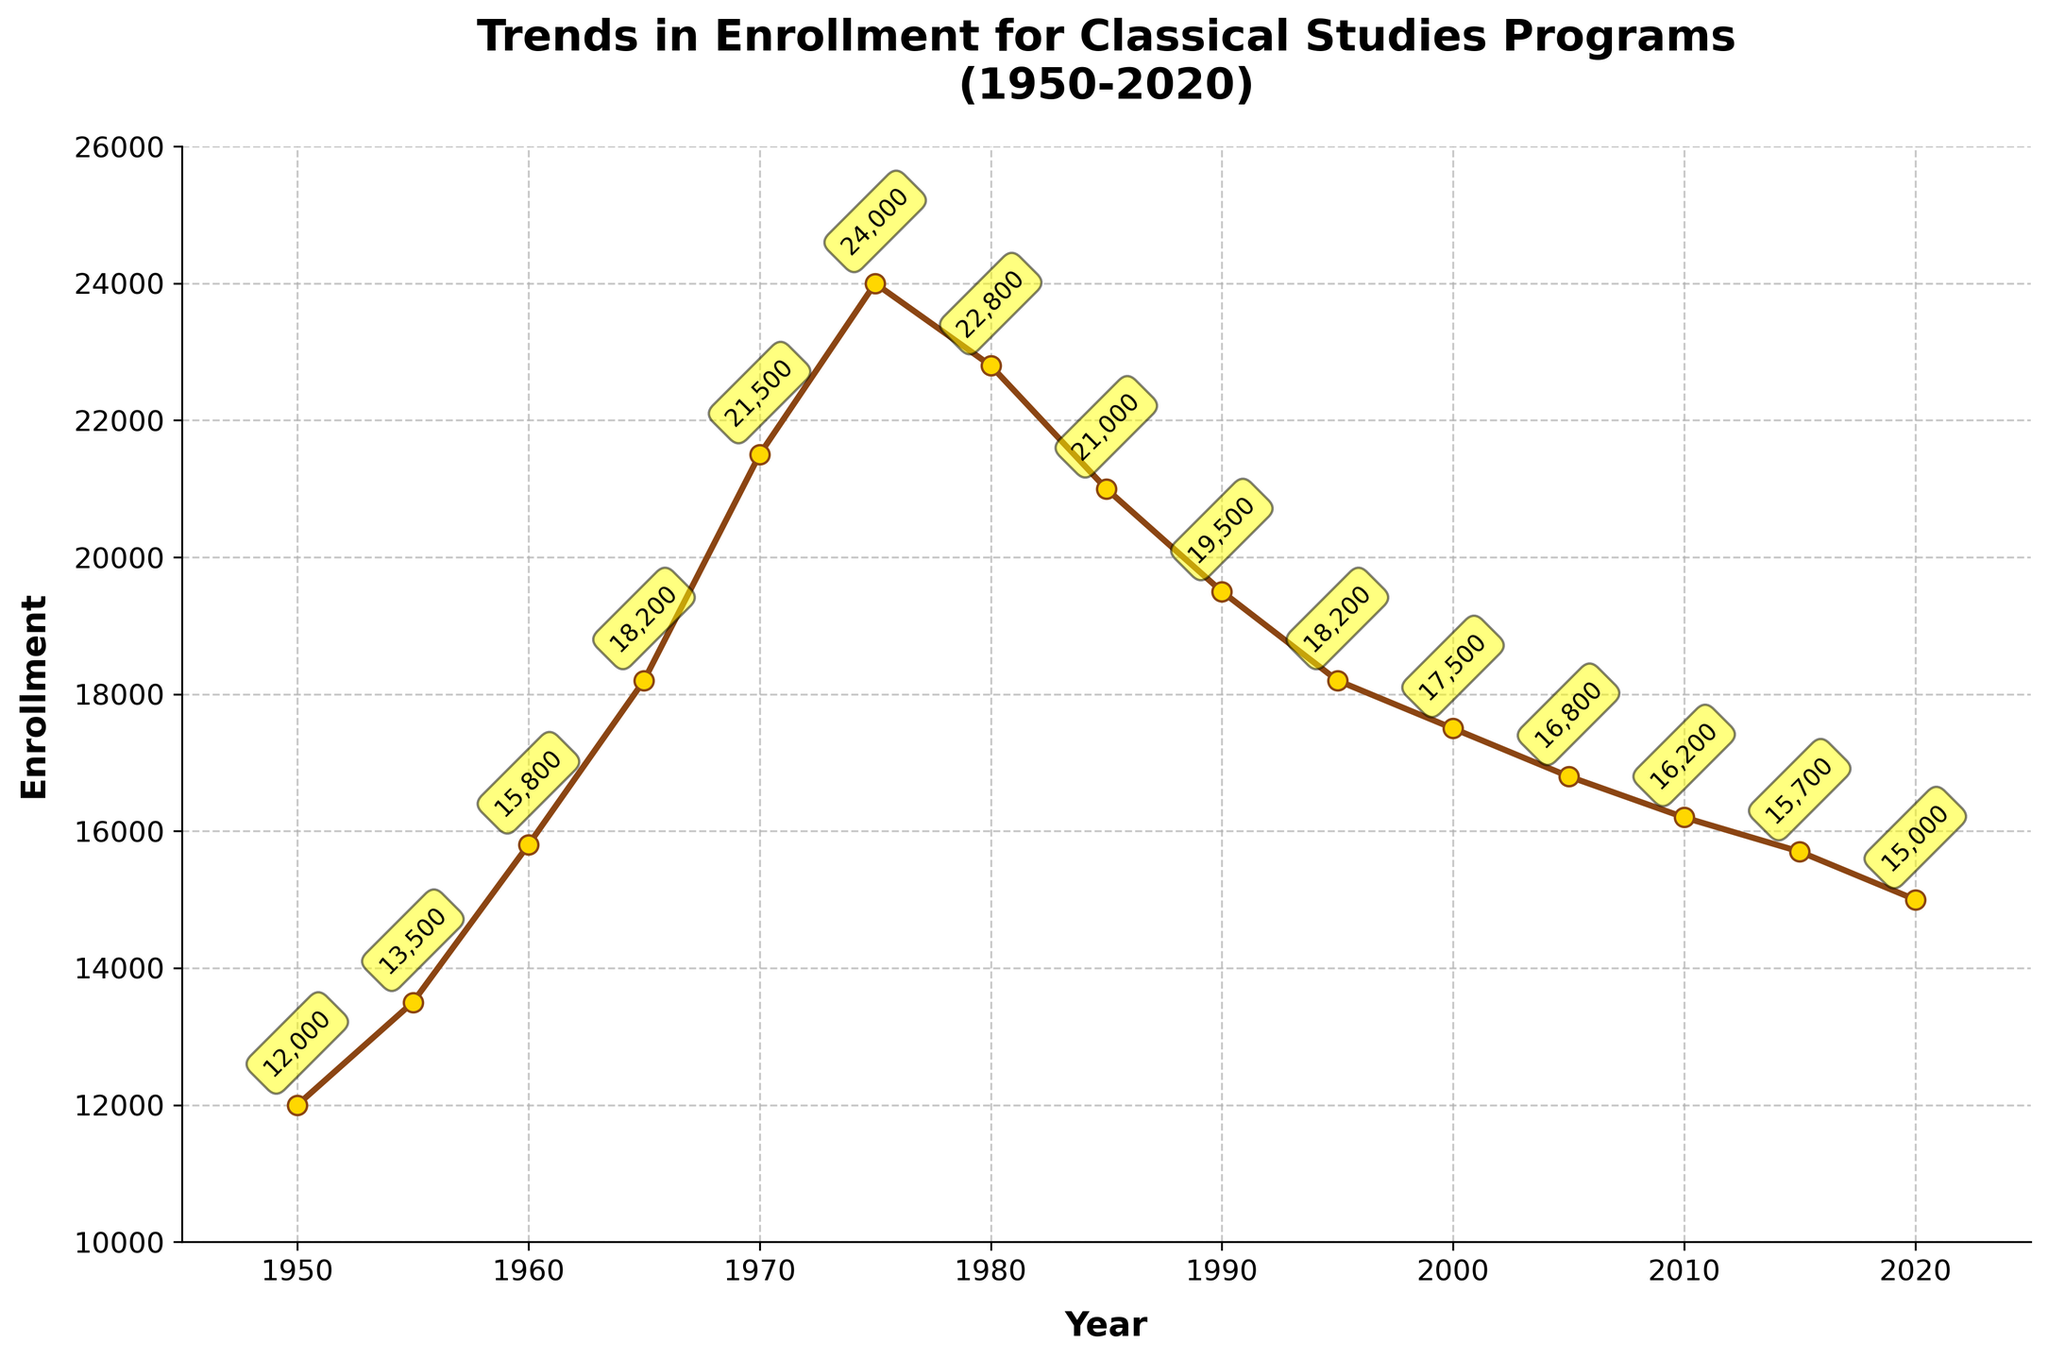What year saw the highest enrollment in Classical Studies programs? Looking at the figure, the enrollment peaked in the year 1975, which is shown to be the highest point on the line.
Answer: 1975 How much did the enrollment decrease from its peak in 1975 to 2020? By finding the enrollment values for 1975 and 2020, we see 24000 in 1975 and 15000 in 2020. The difference is 24000 - 15000 = 9000.
Answer: 9000 Compare the enrollment trends between 1950 and 1985; which period had a steeper increase in the Classical Studies enrollments? Between 1950 and 1985, enrollment increased from 12000 to 21000. The increase from 1950-1975 was very steep (12000 to 24000), while from 1975-1985 it decreased from 24000 to 21000. Hence, the period between 1950 and 1975 had a steeper increase.
Answer: 1950-1975 What is the average enrollment from 1950 to 2020? Sum the enrollments for all years from 1950 to 2020, then divide by the number of years: (12000 + 13500 + 15800 + 18200 + 21500 + 24000 + 22800 + 21000 + 19500 + 18200 + 17500 + 16800 + 16200 + 15700 + 15000) / 15 = 18833.33
Answer: 18833.33 During which decade did the enrollment see the largest decline? The figure shows the steepest decline occurred between 1975 (24000) and 1985 (21000), a drop of 3000, compared to other decades’ declines.
Answer: 1975-1985 Identify the first year when the enrollment started to decline. Up to 1975, the enrollment had been rising. The decline starts from 1975 onwards, as shown by the downward trajectory after this year.
Answer: 1975 What is the total drop in enrollment from 1980 to 2020? Enrollment in 1980 was 22800, and in 2020 it was 15000. The total drop is 22800 - 15000 = 7800.
Answer: 7800 Which two consecutive years had the smallest change in enrollment, and what was the change? The minimal change is between 2015 (15700) and 2020 (15000) with a difference of 700 (15700 - 15000 = 700), which is the smallest compared to other consecutive years.
Answer: 2015-2020, 700 